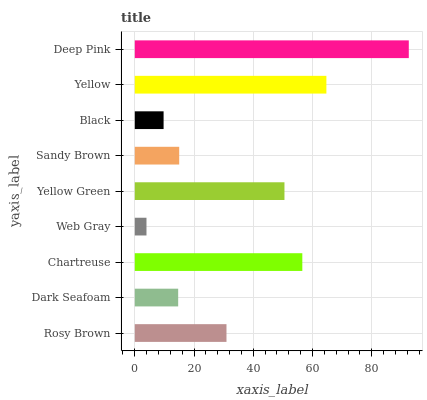Is Web Gray the minimum?
Answer yes or no. Yes. Is Deep Pink the maximum?
Answer yes or no. Yes. Is Dark Seafoam the minimum?
Answer yes or no. No. Is Dark Seafoam the maximum?
Answer yes or no. No. Is Rosy Brown greater than Dark Seafoam?
Answer yes or no. Yes. Is Dark Seafoam less than Rosy Brown?
Answer yes or no. Yes. Is Dark Seafoam greater than Rosy Brown?
Answer yes or no. No. Is Rosy Brown less than Dark Seafoam?
Answer yes or no. No. Is Rosy Brown the high median?
Answer yes or no. Yes. Is Rosy Brown the low median?
Answer yes or no. Yes. Is Yellow Green the high median?
Answer yes or no. No. Is Deep Pink the low median?
Answer yes or no. No. 